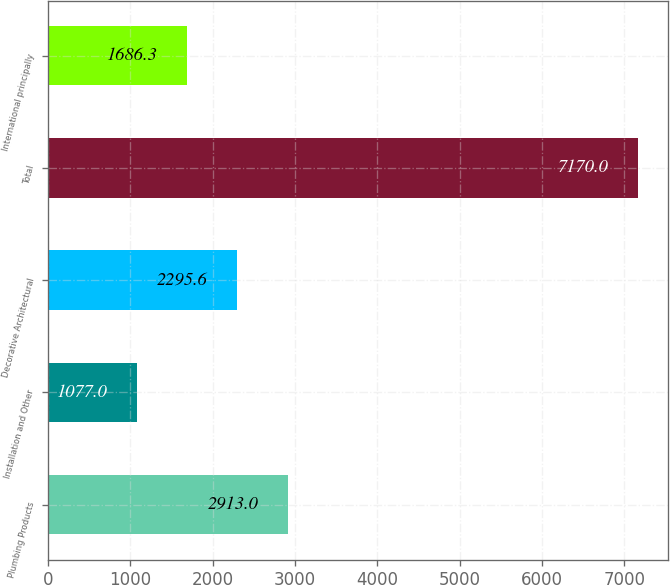Convert chart. <chart><loc_0><loc_0><loc_500><loc_500><bar_chart><fcel>Plumbing Products<fcel>Installation and Other<fcel>Decorative Architectural<fcel>Total<fcel>International principally<nl><fcel>2913<fcel>1077<fcel>2295.6<fcel>7170<fcel>1686.3<nl></chart> 